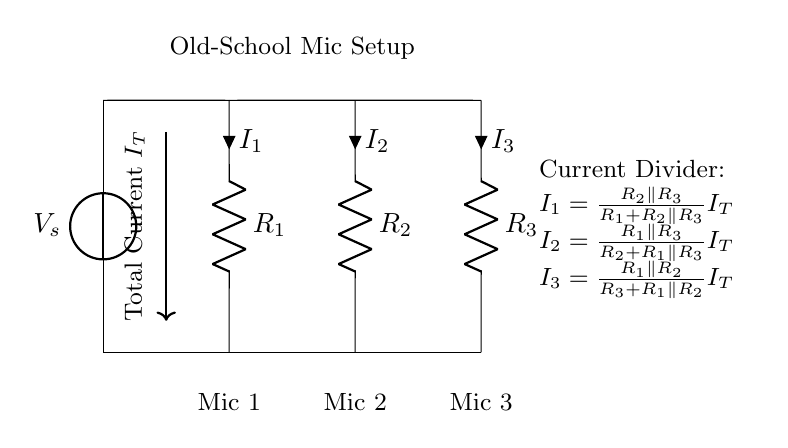What is the source voltage in the circuit? The source voltage is indicated as V_s in the circuit, which is the voltage supplied to the entire setup.
Answer: V_s What type of circuit is represented by this diagram? The diagram represents a parallel circuit, as evidenced by multiple components connected across the same two nodes, providing separate paths for current.
Answer: Parallel How many resistors are in this setup? There are three resistors shown, labeled as R1, R2, and R3 in the diagram.
Answer: Three What is the total current entering the circuit? The total current entering the circuit is denoted as I_T, which is the current coming from the voltage source and splits among the parallel branches.
Answer: I_T Which microphone is associated with the current I1? Microphone 1 is the one associated with the current I1, which is calculated using the formula provided in the diagram.
Answer: Mic 1 What formula is used to calculate current I1? The formula to calculate current I1 is I1 = (R2 parallel R3) / (R1 + R2 parallel R3) * I_T. This shows how I1 is derived from the resistances and total current.
Answer: I1 = (R2 parallel R3) / (R1 + R2 parallel R3) * I_T What does the node labeled "Old-School Mic Setup" represent? The node labeled "Old-School Mic Setup" indicates the section of the circuit where the microphones are connected and illustrates the purpose of this arrangement in distributing current.
Answer: Microphone connections 